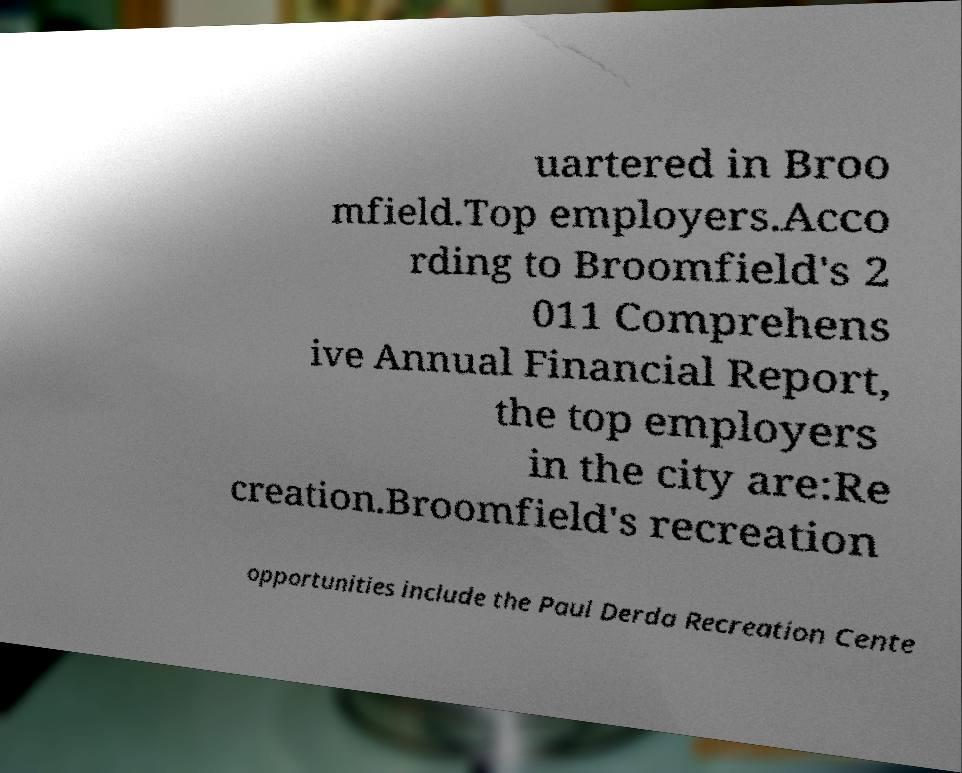There's text embedded in this image that I need extracted. Can you transcribe it verbatim? uartered in Broo mfield.Top employers.Acco rding to Broomfield's 2 011 Comprehens ive Annual Financial Report, the top employers in the city are:Re creation.Broomfield's recreation opportunities include the Paul Derda Recreation Cente 